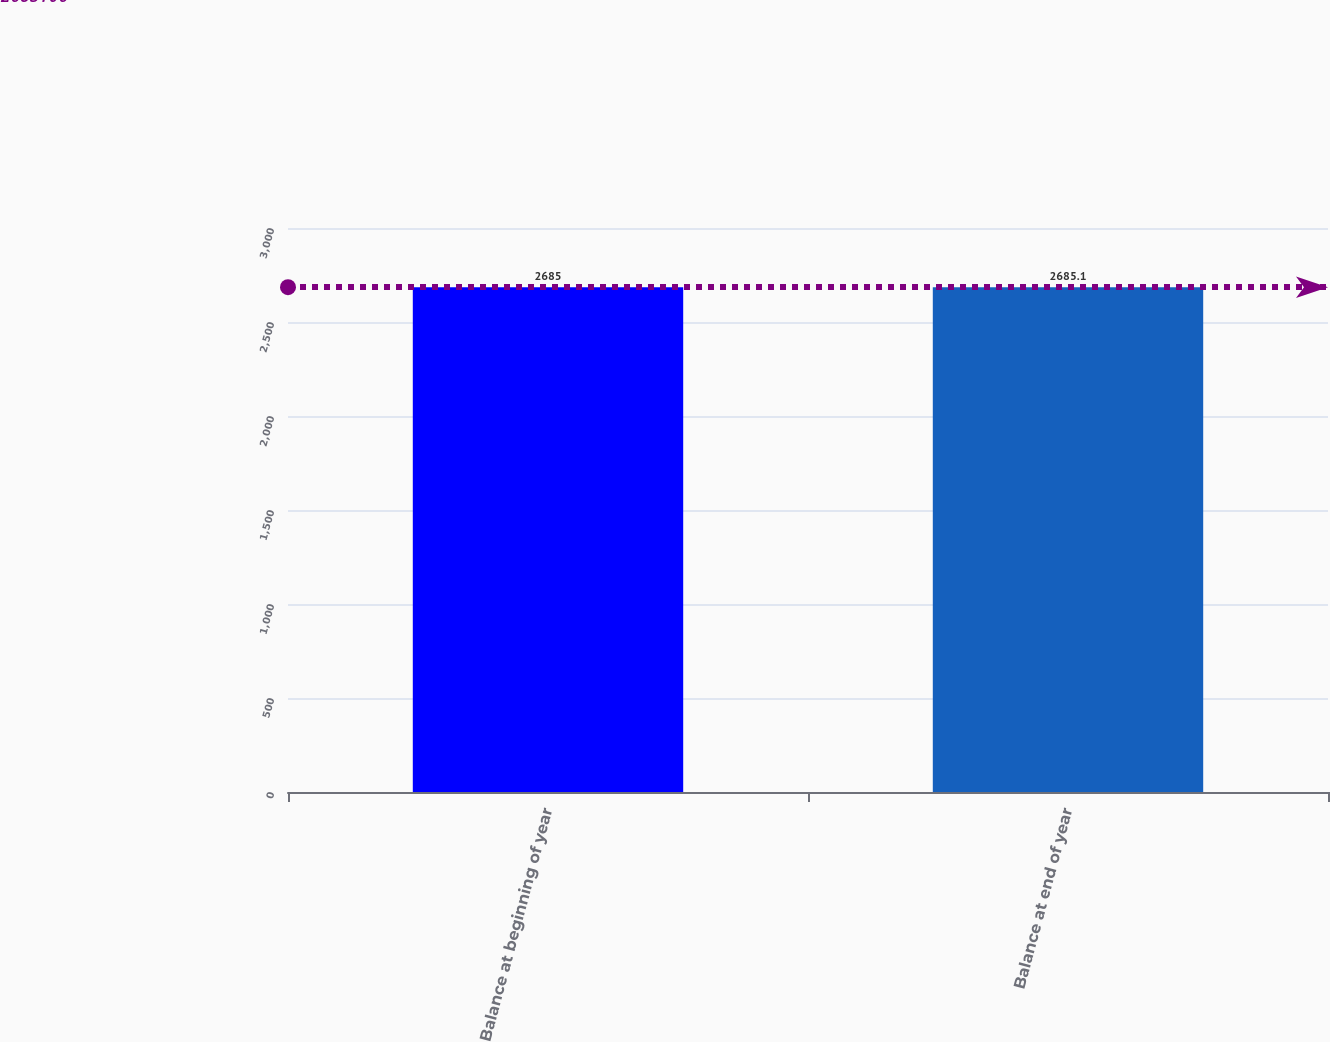Convert chart to OTSL. <chart><loc_0><loc_0><loc_500><loc_500><bar_chart><fcel>Balance at beginning of year<fcel>Balance at end of year<nl><fcel>2685<fcel>2685.1<nl></chart> 